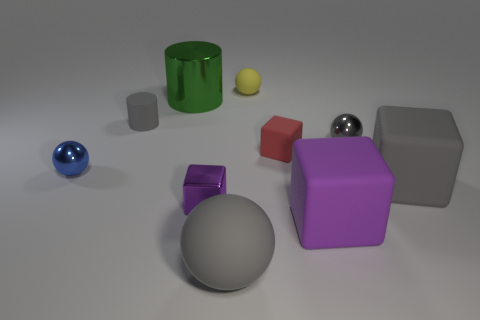Subtract all balls. How many objects are left? 6 Add 1 yellow things. How many yellow things are left? 2 Add 4 big green rubber cylinders. How many big green rubber cylinders exist? 4 Subtract 0 cyan cubes. How many objects are left? 10 Subtract all yellow balls. Subtract all large purple objects. How many objects are left? 8 